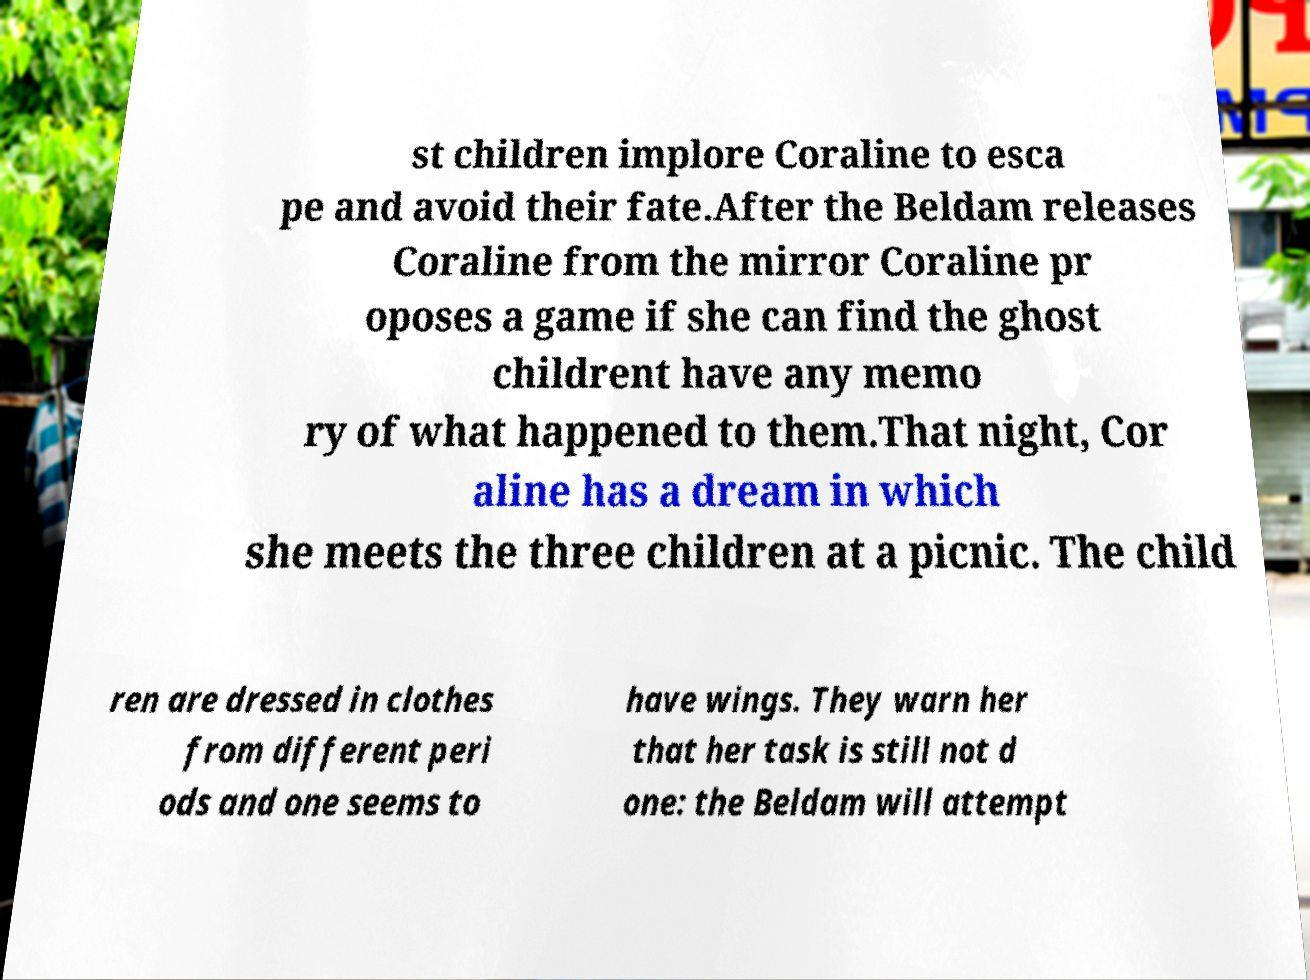There's text embedded in this image that I need extracted. Can you transcribe it verbatim? st children implore Coraline to esca pe and avoid their fate.After the Beldam releases Coraline from the mirror Coraline pr oposes a game if she can find the ghost childrent have any memo ry of what happened to them.That night, Cor aline has a dream in which she meets the three children at a picnic. The child ren are dressed in clothes from different peri ods and one seems to have wings. They warn her that her task is still not d one: the Beldam will attempt 